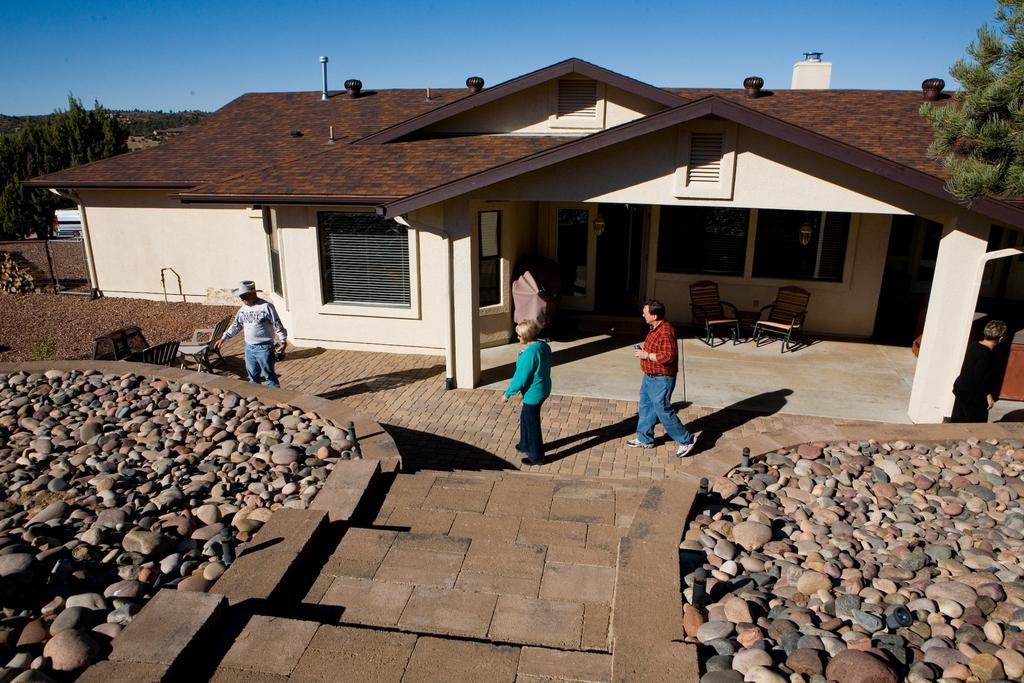How many people are present in the image? There are people in the image, but the exact number cannot be determined from the provided facts. What type of furniture is visible in the image? There are chairs in the image. What type of structure is present in the image? There is a house in the image. What architectural features can be seen in the image? There are windows in the image. What type of natural elements are present in the image? There are rocks and trees in the image. What is visible in the sky in the image? The sky is visible in the image. What type of star can be seen shining brightly in the image? There is no star visible in the image; only the sky is mentioned. What type of notebook is being used by the people in the image? There is no mention of a notebook in the image. 